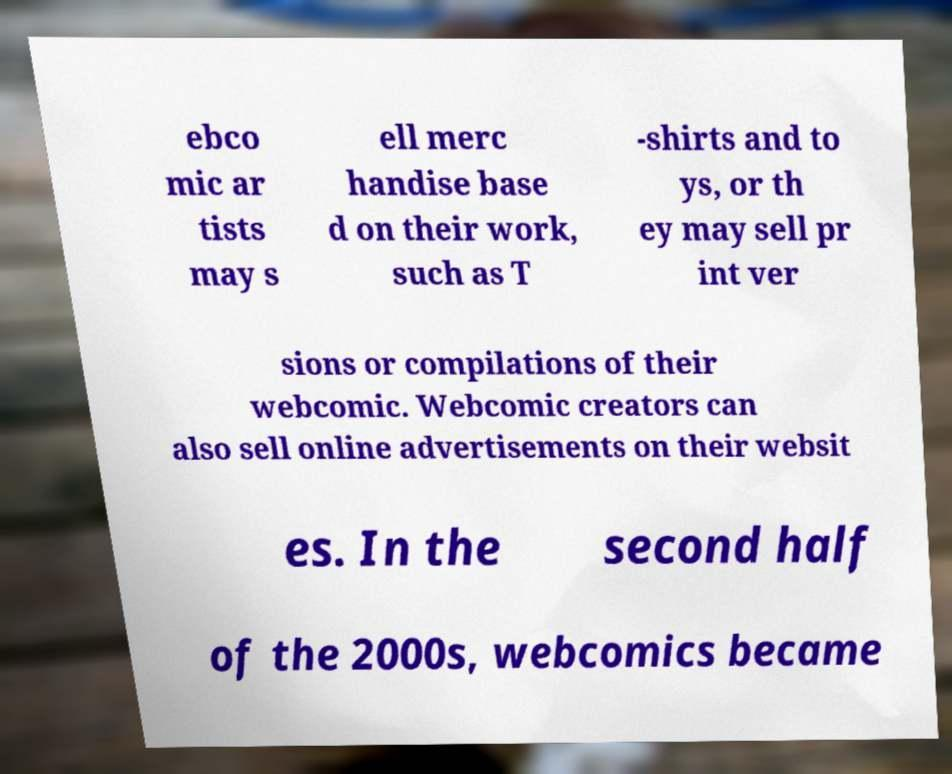What messages or text are displayed in this image? I need them in a readable, typed format. ebco mic ar tists may s ell merc handise base d on their work, such as T -shirts and to ys, or th ey may sell pr int ver sions or compilations of their webcomic. Webcomic creators can also sell online advertisements on their websit es. In the second half of the 2000s, webcomics became 